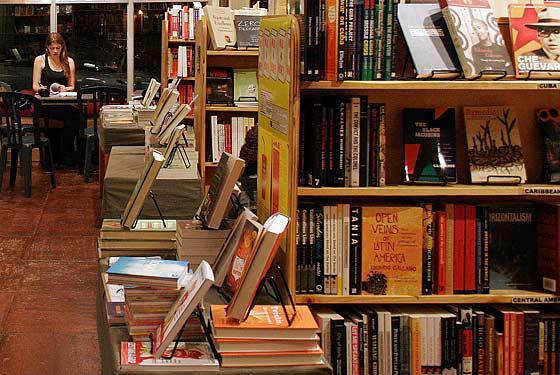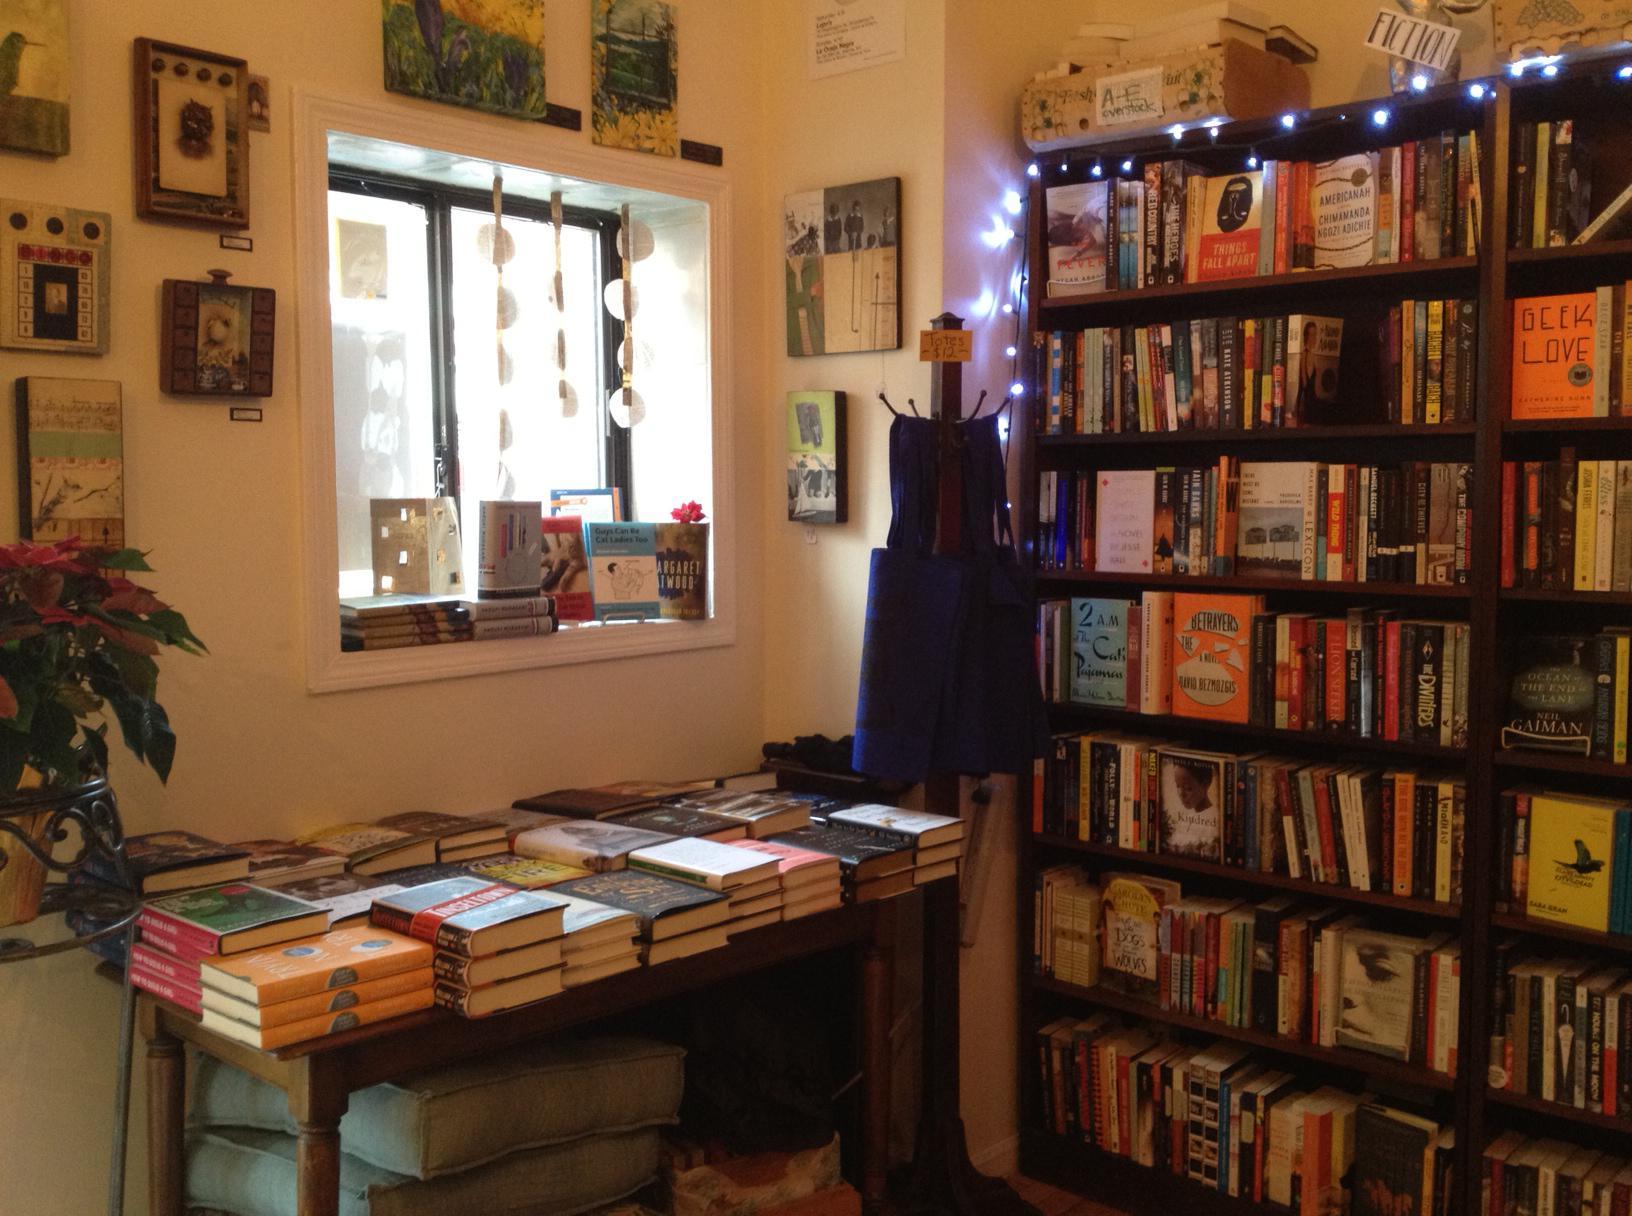The first image is the image on the left, the second image is the image on the right. For the images shown, is this caption "Ceiling lights are visible in both images." true? Answer yes or no. No. The first image is the image on the left, the second image is the image on the right. Given the left and right images, does the statement "Seats are available in the reading area in the image on the right." hold true? Answer yes or no. No. 